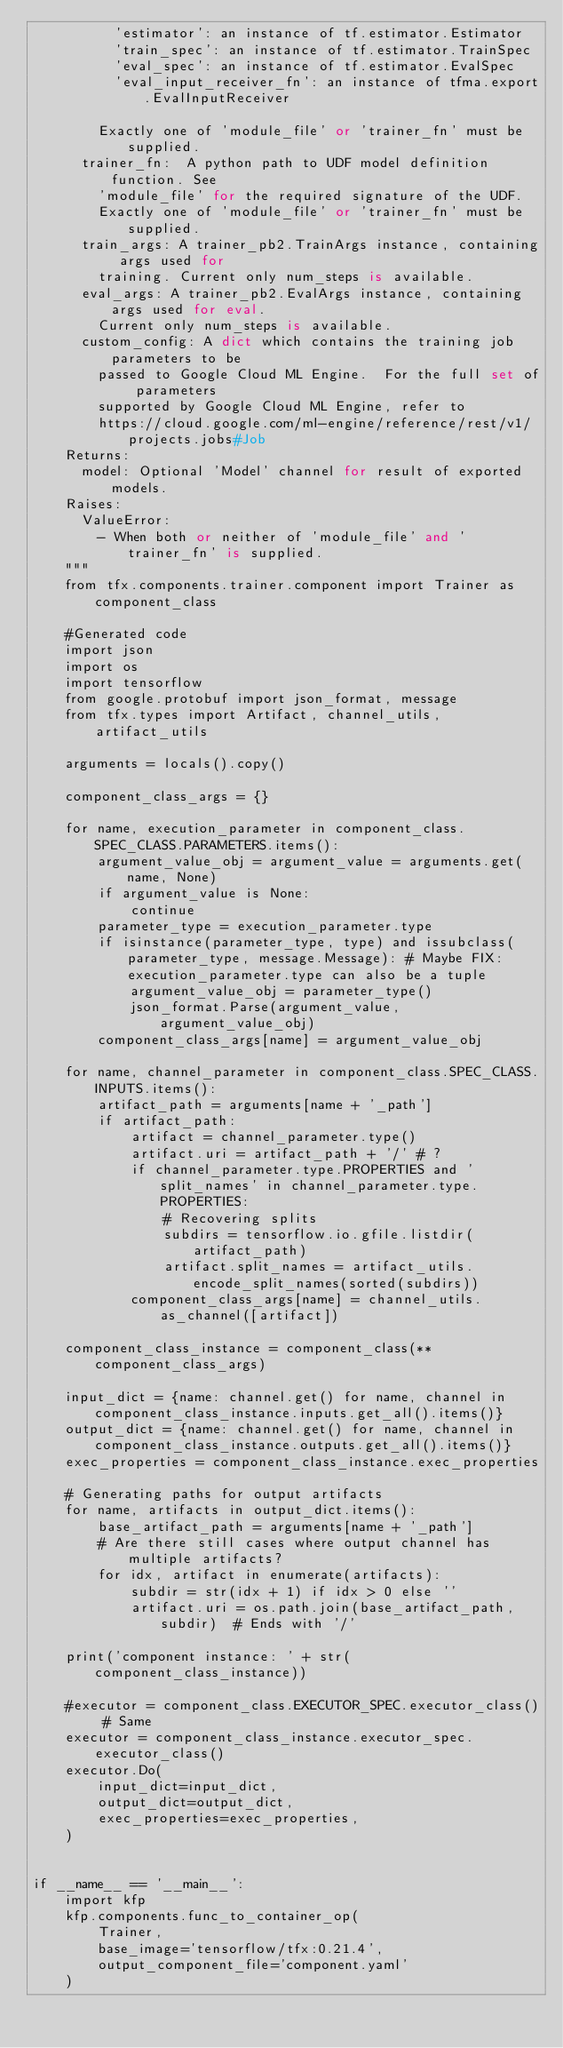<code> <loc_0><loc_0><loc_500><loc_500><_Python_>          'estimator': an instance of tf.estimator.Estimator
          'train_spec': an instance of tf.estimator.TrainSpec
          'eval_spec': an instance of tf.estimator.EvalSpec
          'eval_input_receiver_fn': an instance of tfma.export.EvalInputReceiver

        Exactly one of 'module_file' or 'trainer_fn' must be supplied.
      trainer_fn:  A python path to UDF model definition function. See
        'module_file' for the required signature of the UDF.
        Exactly one of 'module_file' or 'trainer_fn' must be supplied.
      train_args: A trainer_pb2.TrainArgs instance, containing args used for
        training. Current only num_steps is available.
      eval_args: A trainer_pb2.EvalArgs instance, containing args used for eval.
        Current only num_steps is available.
      custom_config: A dict which contains the training job parameters to be
        passed to Google Cloud ML Engine.  For the full set of parameters
        supported by Google Cloud ML Engine, refer to
        https://cloud.google.com/ml-engine/reference/rest/v1/projects.jobs#Job
    Returns:
      model: Optional 'Model' channel for result of exported models.
    Raises:
      ValueError:
        - When both or neither of 'module_file' and 'trainer_fn' is supplied.
    """
    from tfx.components.trainer.component import Trainer as component_class

    #Generated code
    import json
    import os
    import tensorflow
    from google.protobuf import json_format, message
    from tfx.types import Artifact, channel_utils, artifact_utils

    arguments = locals().copy()

    component_class_args = {}

    for name, execution_parameter in component_class.SPEC_CLASS.PARAMETERS.items():
        argument_value_obj = argument_value = arguments.get(name, None)
        if argument_value is None:
            continue
        parameter_type = execution_parameter.type
        if isinstance(parameter_type, type) and issubclass(parameter_type, message.Message): # Maybe FIX: execution_parameter.type can also be a tuple
            argument_value_obj = parameter_type()
            json_format.Parse(argument_value, argument_value_obj)
        component_class_args[name] = argument_value_obj

    for name, channel_parameter in component_class.SPEC_CLASS.INPUTS.items():
        artifact_path = arguments[name + '_path']
        if artifact_path:
            artifact = channel_parameter.type()
            artifact.uri = artifact_path + '/' # ?
            if channel_parameter.type.PROPERTIES and 'split_names' in channel_parameter.type.PROPERTIES:
                # Recovering splits
                subdirs = tensorflow.io.gfile.listdir(artifact_path)
                artifact.split_names = artifact_utils.encode_split_names(sorted(subdirs))
            component_class_args[name] = channel_utils.as_channel([artifact])

    component_class_instance = component_class(**component_class_args)

    input_dict = {name: channel.get() for name, channel in component_class_instance.inputs.get_all().items()}
    output_dict = {name: channel.get() for name, channel in component_class_instance.outputs.get_all().items()}
    exec_properties = component_class_instance.exec_properties

    # Generating paths for output artifacts
    for name, artifacts in output_dict.items():
        base_artifact_path = arguments[name + '_path']
        # Are there still cases where output channel has multiple artifacts?
        for idx, artifact in enumerate(artifacts):
            subdir = str(idx + 1) if idx > 0 else ''
            artifact.uri = os.path.join(base_artifact_path, subdir)  # Ends with '/'

    print('component instance: ' + str(component_class_instance))

    #executor = component_class.EXECUTOR_SPEC.executor_class() # Same
    executor = component_class_instance.executor_spec.executor_class()
    executor.Do(
        input_dict=input_dict,
        output_dict=output_dict,
        exec_properties=exec_properties,
    )


if __name__ == '__main__':
    import kfp
    kfp.components.func_to_container_op(
        Trainer,
        base_image='tensorflow/tfx:0.21.4',
        output_component_file='component.yaml'
    )
</code> 